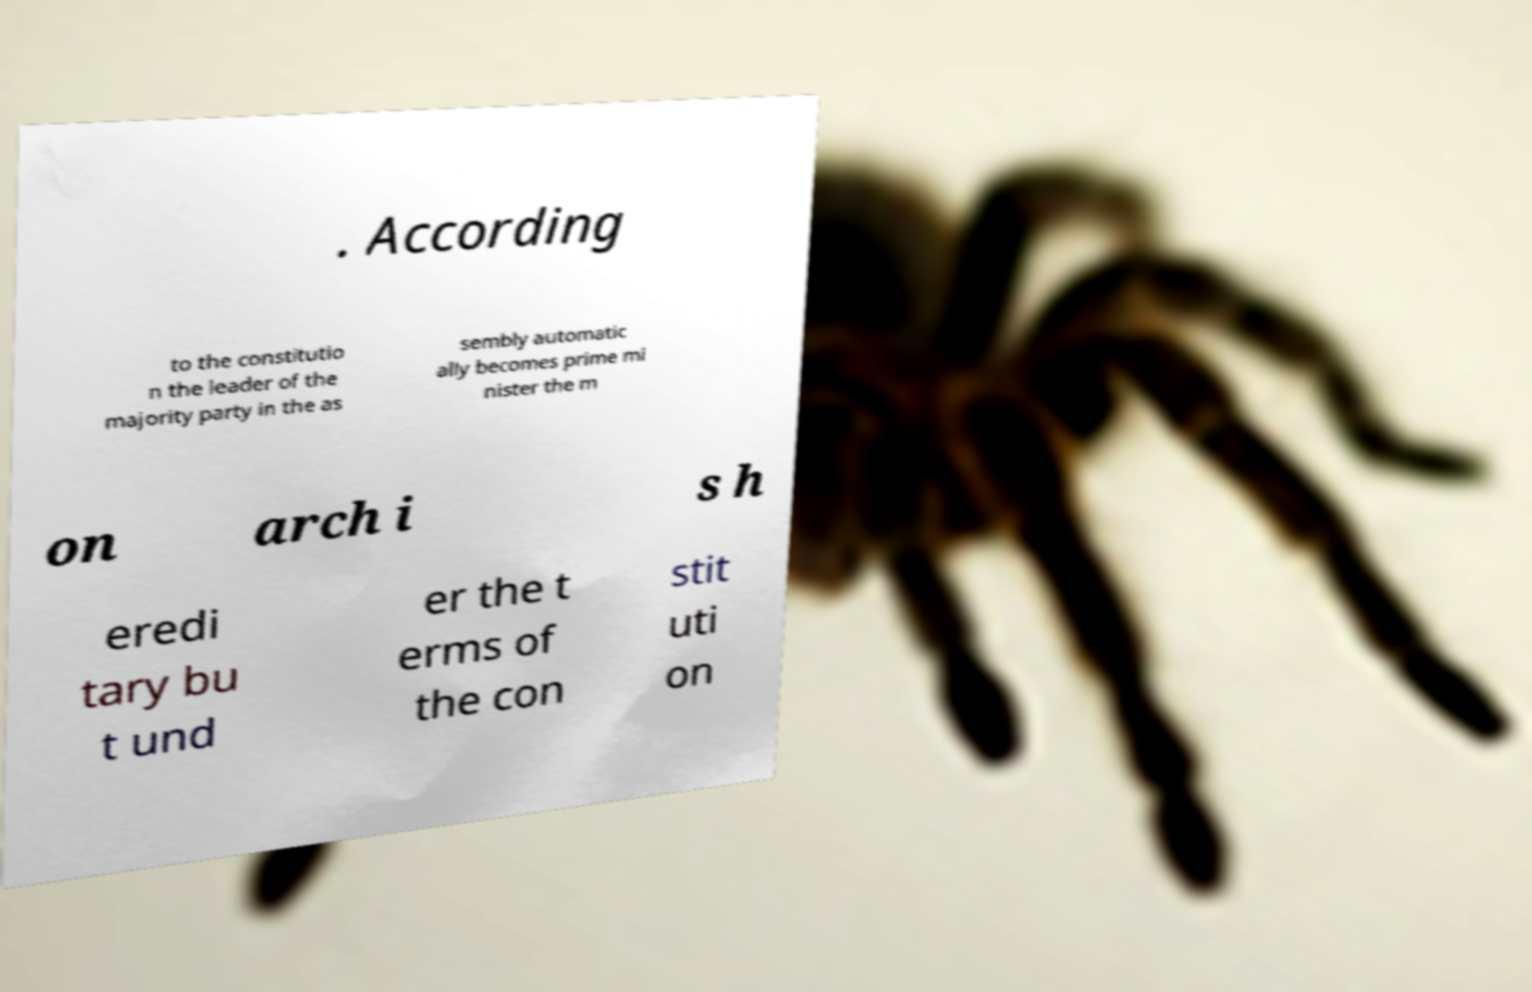Could you assist in decoding the text presented in this image and type it out clearly? . According to the constitutio n the leader of the majority party in the as sembly automatic ally becomes prime mi nister the m on arch i s h eredi tary bu t und er the t erms of the con stit uti on 